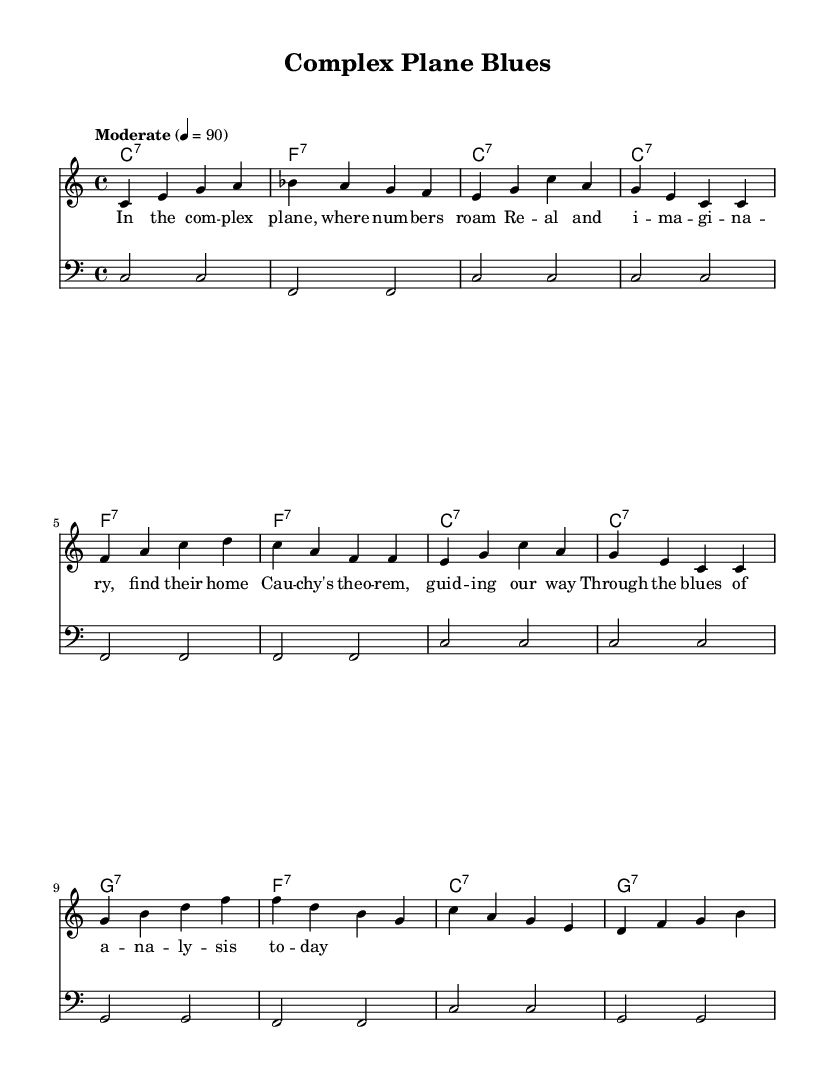What is the key signature of this music? The key signature is C major, which has no sharps or flats.
Answer: C major What is the time signature of this composition? The time signature indicated in the music is 4/4, which means there are four beats in each measure.
Answer: 4/4 What is the tempo marking for this piece? The tempo marking indicates a moderate speed of 90 beats per minute.
Answer: Moderate 4 = 90 How many bars are there in the melody section? The melody section consists of eight bars, as indicated by the grouping of notes and rests in the staff.
Answer: 8 What chords are primarily used in this blues composition? The composition primarily features C7, F7, and G7 chords, which are typical in blues music.
Answer: C7, F7, G7 Which mathematical theorem is referenced in the lyrics? The lyrics mention Cauchy's theorem, which relates to complex analysis in mathematics.
Answer: Cauchy's theorem What is the form of the lyrics in this blues piece? The lyrics follow a traditional aab structure, typical in blues music, where the first two lines are repeated in the last line.
Answer: AAB 